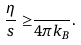Convert formula to latex. <formula><loc_0><loc_0><loc_500><loc_500>\frac { \eta } { s } \geq & \frac { } { 4 \pi k _ { B } } .</formula> 